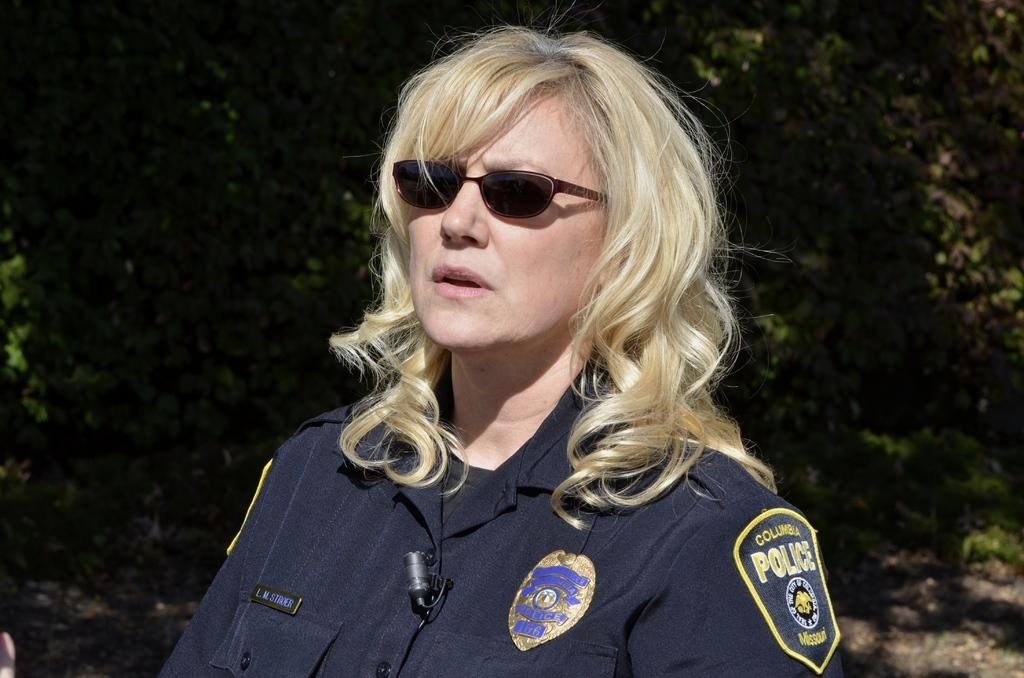Who is the main subject in the image? There is a lady in the center of the image. What is the lady wearing? The lady is wearing a uniform and goggles. What can be seen in the background of the image? There are trees in the background of the image. What is visible at the bottom of the image? The ground is visible at the bottom of the image. What type of soup is being served in the image? There is no soup present in the image. Who is the manager of the planes in the image? There are no planes or managers mentioned in the image. 